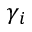Convert formula to latex. <formula><loc_0><loc_0><loc_500><loc_500>\gamma _ { i }</formula> 